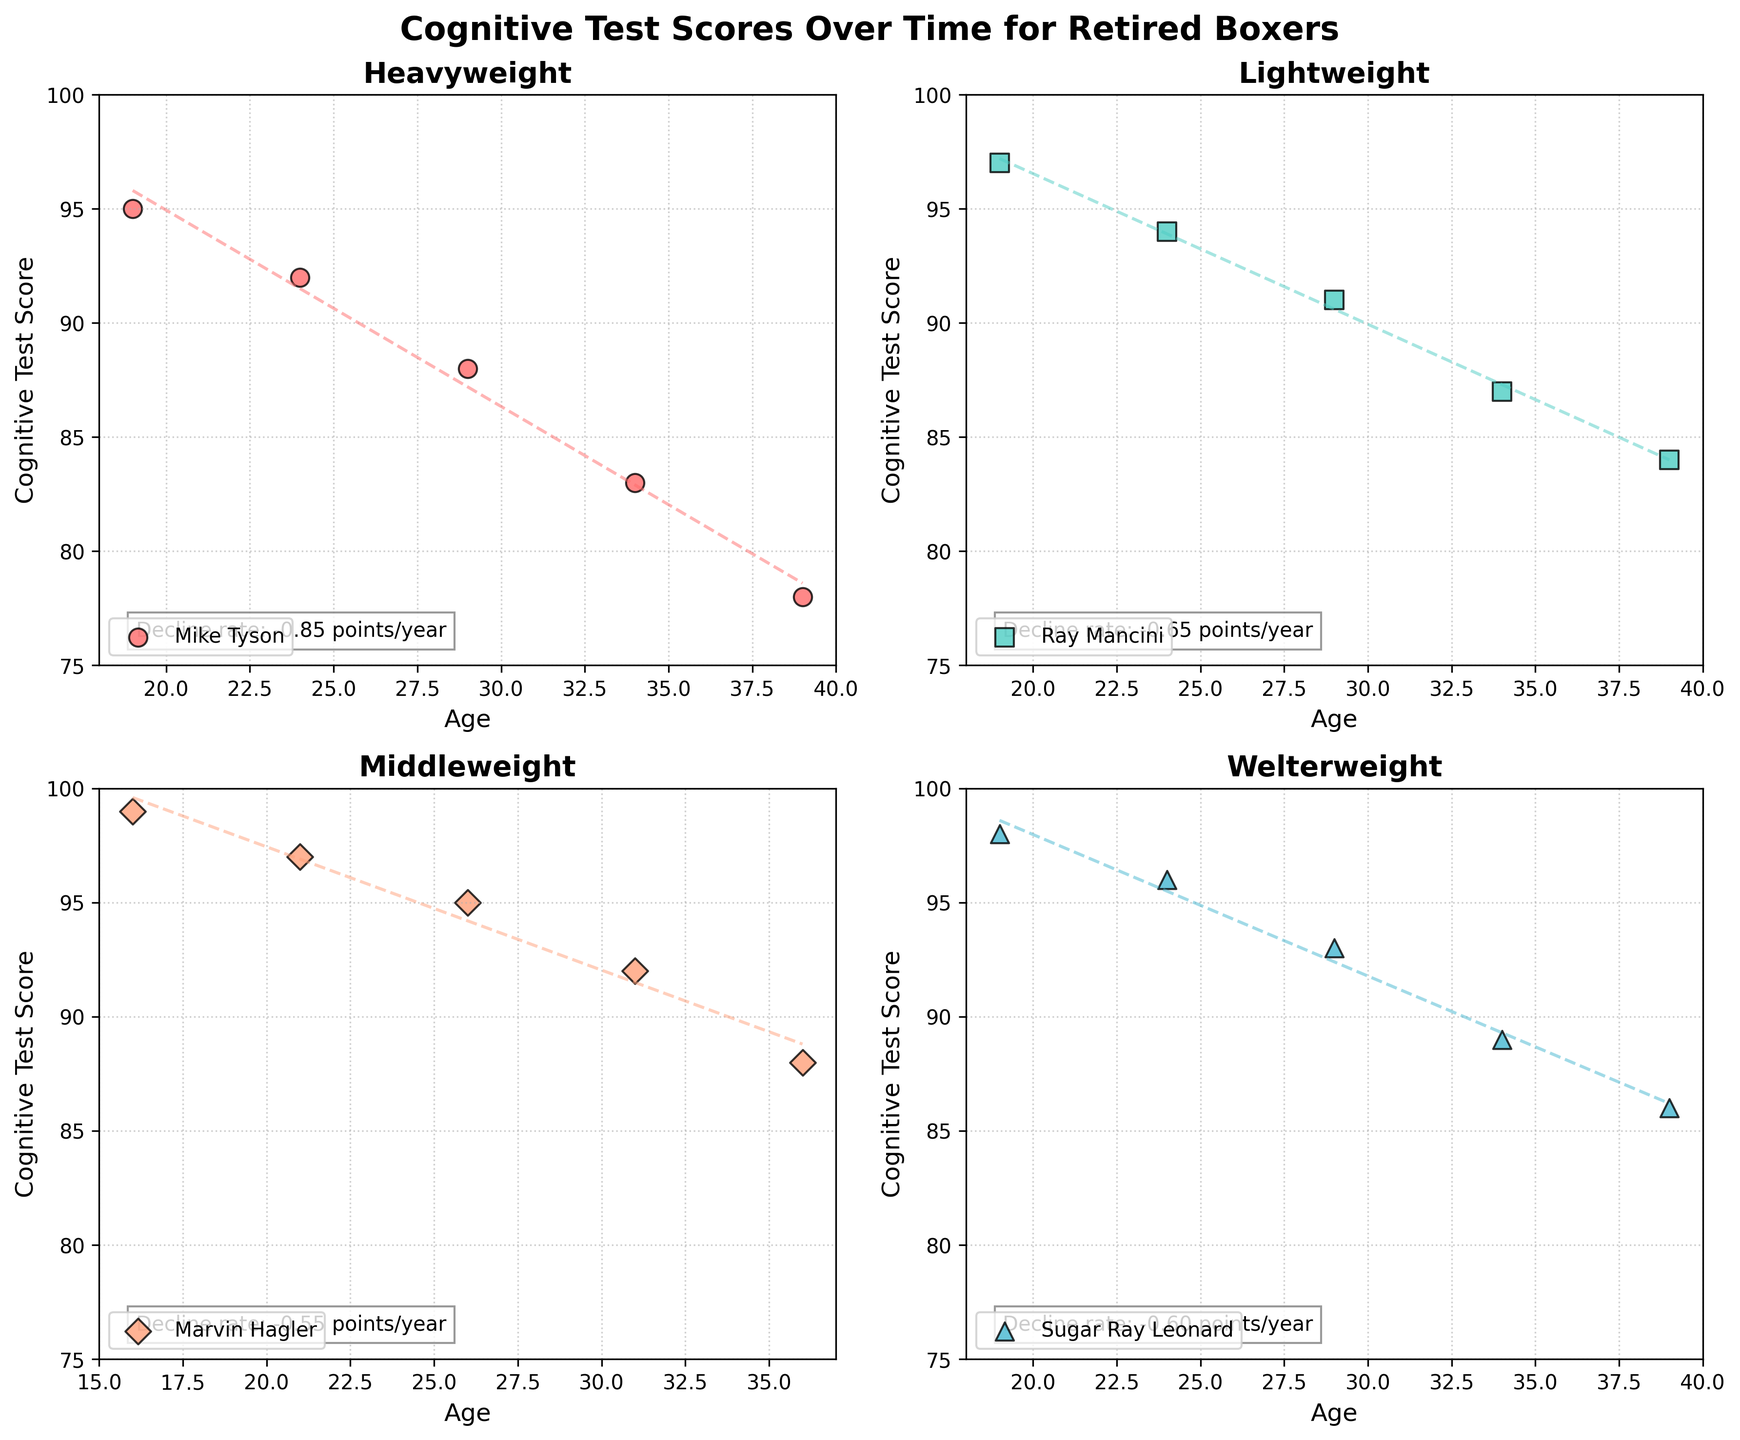What is the title of the figure? The title is located at the top center of the figure. It reads "Cognitive Test Scores Over Time for Retired Boxers" in a bold font.
Answer: Cognitive Test Scores Over Time for Retired Boxers How many weight classes are represented in the subplots? Each subplot is titled with the name of a weight class. There are four subplots with titles: "Heavyweight," "Lightweight," "Welterweight," and "Middleweight".
Answer: Four Which weight class shows the steepest decline rate in cognitive test scores? Each subplot has a text box mentioning the decline rate. The figures show the rates for each weight class. Comparing these, we find the steepest rate.
Answer: Heavyweight What are the markers used to represent data points for each weight class? The markers can be identified by their distinct shapes seen in the legend of each subplot. Heavyweight uses circles, Lightweight uses squares, Welterweight uses triangles, and Middleweight uses diamonds.
Answer: Circles, Squares, Triangles, Diamonds How does the cognitive test score trend for "Mike Tyson" evolve over time? In the Heavyweight subplot, observe how Mike Tyson's data points decline from 95 at age 19 to 78 at age 39, along with the downward trend lines.
Answer: Declines Which boxer in the Middleweight class had the highest cognitive test score at the youngest age? Within the Middleweight subplot, at the lowest age (16), Marvin Hagler has a data point at a high cognitive test score of 99.
Answer: Marvin Hagler Are there any boxers whose cognitive test scores never drop below 90? By studying the individual data points in each subplot, note that Ray Mancini's scores always remain above 90. Similarly, Sugar Ray Leonard's scores are above 90 until they drop to 89 at age 34.
Answer: Ray Mancini What is the range of ages for boxers in the Welterweight subplot? On the x-axis of the Welterweight subplot, ages range from the youngest at 19 to the oldest at 39.
Answer: 19 to 39 Between which ages does Mike Tyson show the most significant drop in his cognitive test score? Observing Mike Tyson’s data points in the Heavyweight subplot, the cognitive test score drops significantly between ages 34 (83) and 39 (78), a difference of 5 points.
Answer: 34 to 39 Which weight class has the least number of data points? By counting the data points in each subplot, the Middleweight class, with points at ages 16, 21, 26, 31, and 36, has fewer compared to others.
Answer: Middleweight 